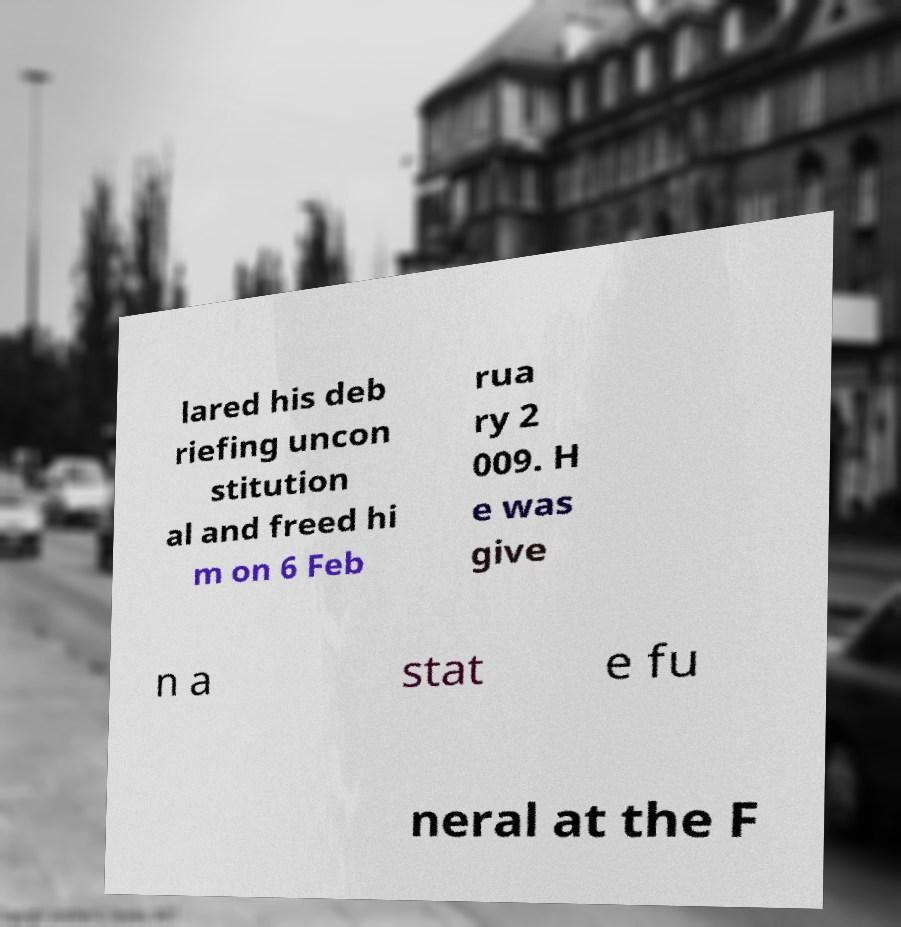For documentation purposes, I need the text within this image transcribed. Could you provide that? lared his deb riefing uncon stitution al and freed hi m on 6 Feb rua ry 2 009. H e was give n a stat e fu neral at the F 